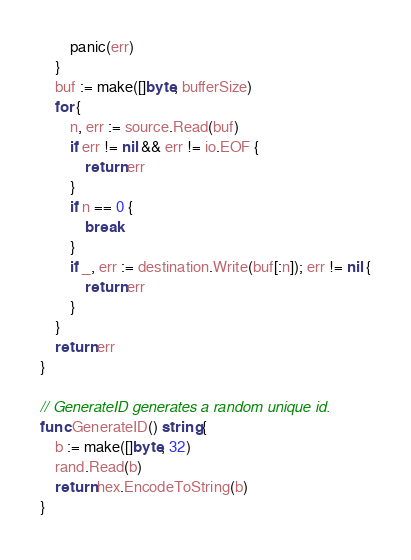Convert code to text. <code><loc_0><loc_0><loc_500><loc_500><_Go_>		panic(err)
	}
	buf := make([]byte, bufferSize)
	for {
		n, err := source.Read(buf)
		if err != nil && err != io.EOF {
			return err
		}
		if n == 0 {
			break
		}
		if _, err := destination.Write(buf[:n]); err != nil {
			return err
		}
	}
	return err
}

// GenerateID generates a random unique id.
func GenerateID() string {
	b := make([]byte, 32)
	rand.Read(b)
	return hex.EncodeToString(b)
}
</code> 